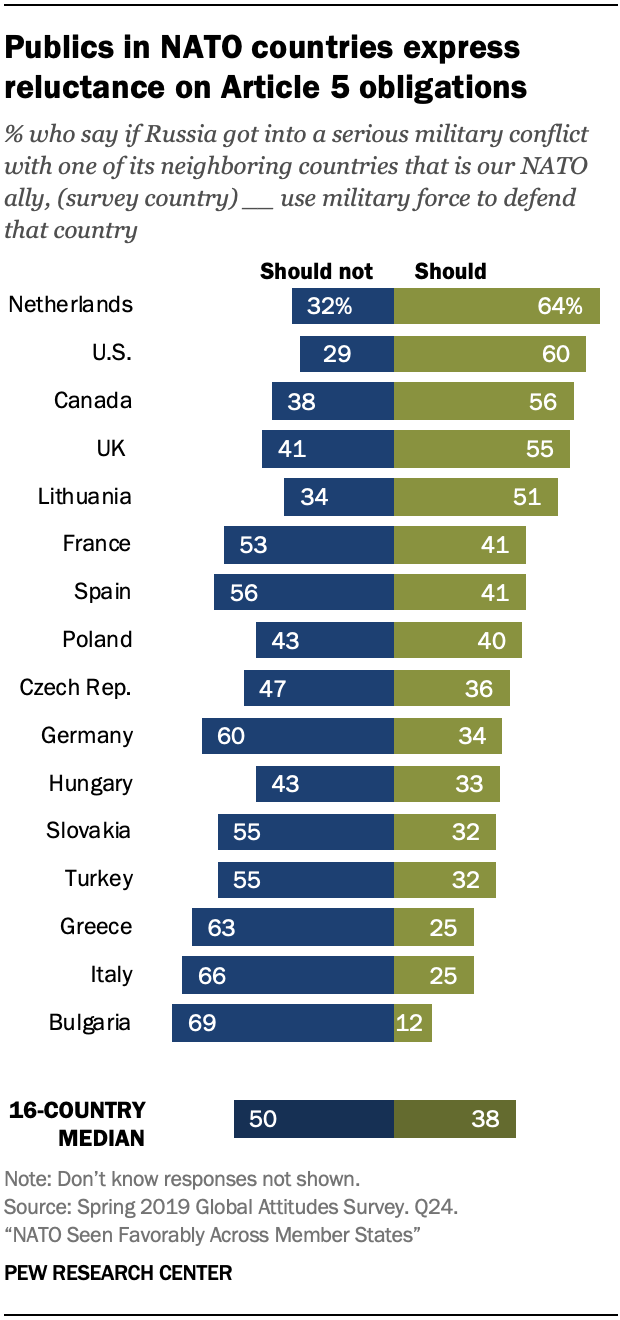List a handful of essential elements in this visual. What is the acceptable value for Spain? 56. The ratio of the blue bar of Poland to the green bar of Turkey is 1.813888889... 